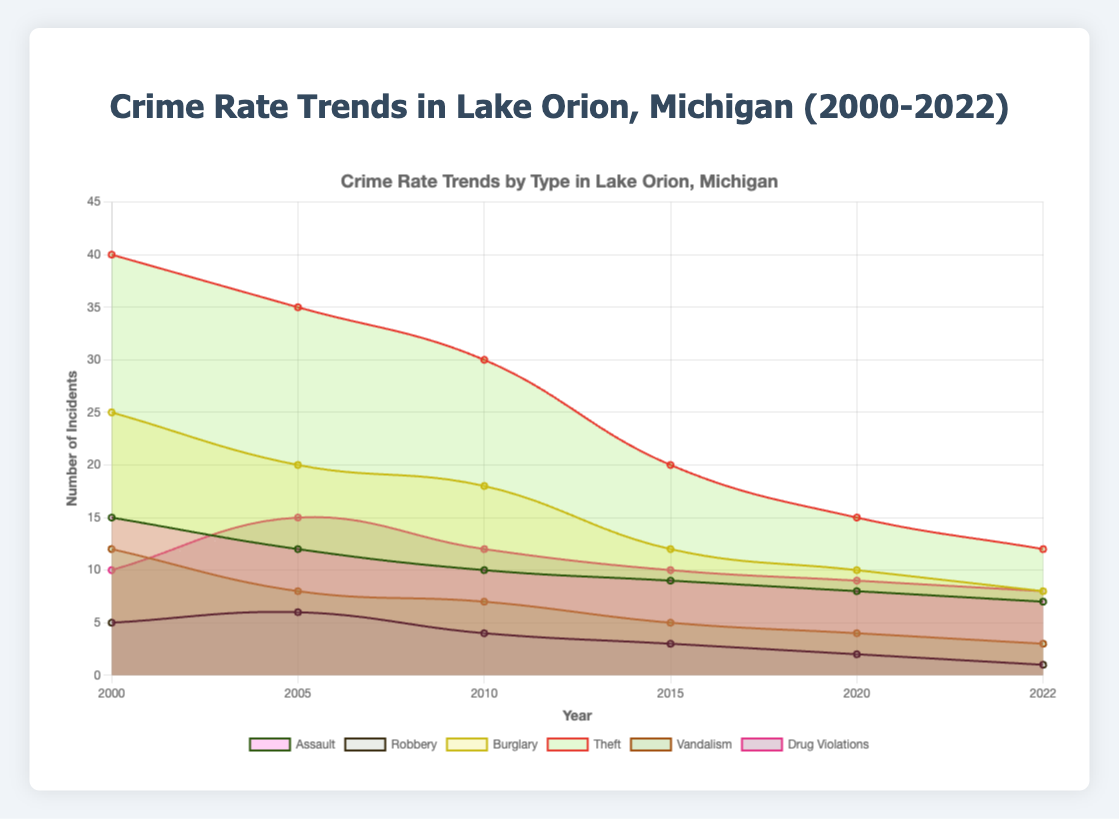What is the title of the chart? The title of the chart is usually displayed at the top, which provides an overview of what the data represents. Here, the title is "Crime Rate Trends in Lake Orion, Michigan (2000-2022)".
Answer: Crime Rate Trends in Lake Orion, Michigan (2000-2022) How many years are represented in the chart? The x-axis of the chart typically represents the timeline, and by counting the labels on the x-axis, we can determine the number of years represented. In this case, the chart shows the crime data for 6 different years.
Answer: 6 Which type of crime had the highest number of incidents in 2000? By examining the areas or lines corresponding to each type of crime in the year 2000, we can identify the one that reaches the highest on the y-axis. Here, "Theft" had the highest number of incidents.
Answer: Theft What is the trend of burglary incidents from 2000 to 2022? To determine the trend, look at the line corresponding to "Burglary" and observe its movement from 2000 to 2022. The incidents decreased from 25 in 2000 to 8 in 2022.
Answer: Decreasing Which type of crime had the most significant decrease in incidents between 2000 and 2022? Calculate the difference in incidents between 2000 and 2022 for each type of crime and determine which type decreased the most. "Theft" decreased from 40 to 12, which is the most significant drop.
Answer: Theft Comparing 2015 to 2022, which crime type decreased the most in number? By comparing the crime data only between these two years, subtract the values in 2022 from those in 2015 for each type. "Theft" decreased by 8 incidents during this period (20 - 12 = 8).
Answer: Theft Which type of crime remained relatively stable over the years? To identify stability, analyze each type of crime's trend lines. "Drug Violations" shows relatively small changes compared to other types of crimes, especially after 2005.
Answer: Drug Violations Did any crime type see an increase in incidents from 2000 to 2022? Look at the trend lines for each crime type and see if any have a positive slope from the start to the end of the period. All types of crimes either decreased or remained stable; none increased.
Answer: No Which crime type had the highest incidents in 2022 and how many? Observe the lines or areas for the year 2022 and identify which one reaches the highest point on the y-axis and check its value. "Theft" had the highest number of incidents in 2022, with 12 incidents.
Answer: Theft, 12 By how much did the number of assault incidents change from 2000 to 2022? Subtract the number of incidents in 2022 from the number in 2000 for "Assault" (15 - 7 = 8). Therefore, the number of assault incidents decreased by 8.
Answer: Decreased by 8 